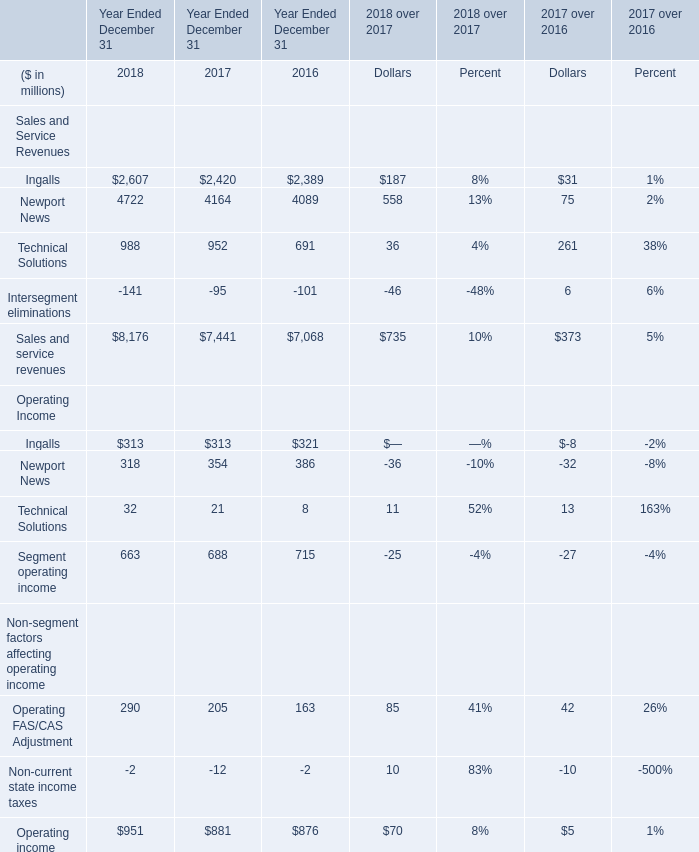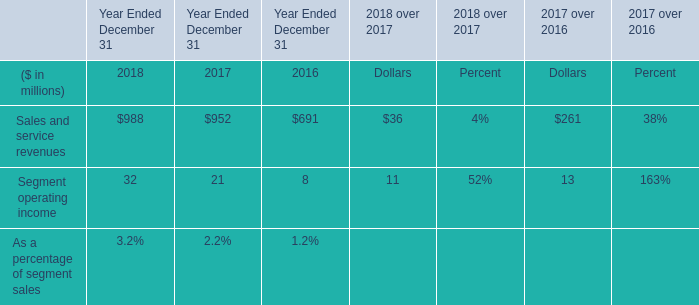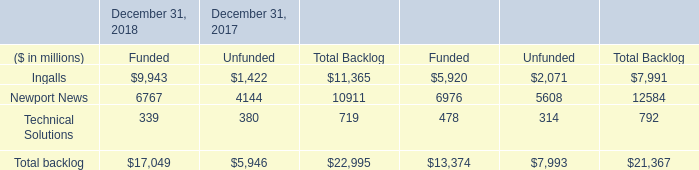What is the average amount of Ingalls of December 31, 2017 Funded, and Ingalls of Year Ended December 31 2016 ? 
Computations: ((5920.0 + 2389.0) / 2)
Answer: 4154.5. 